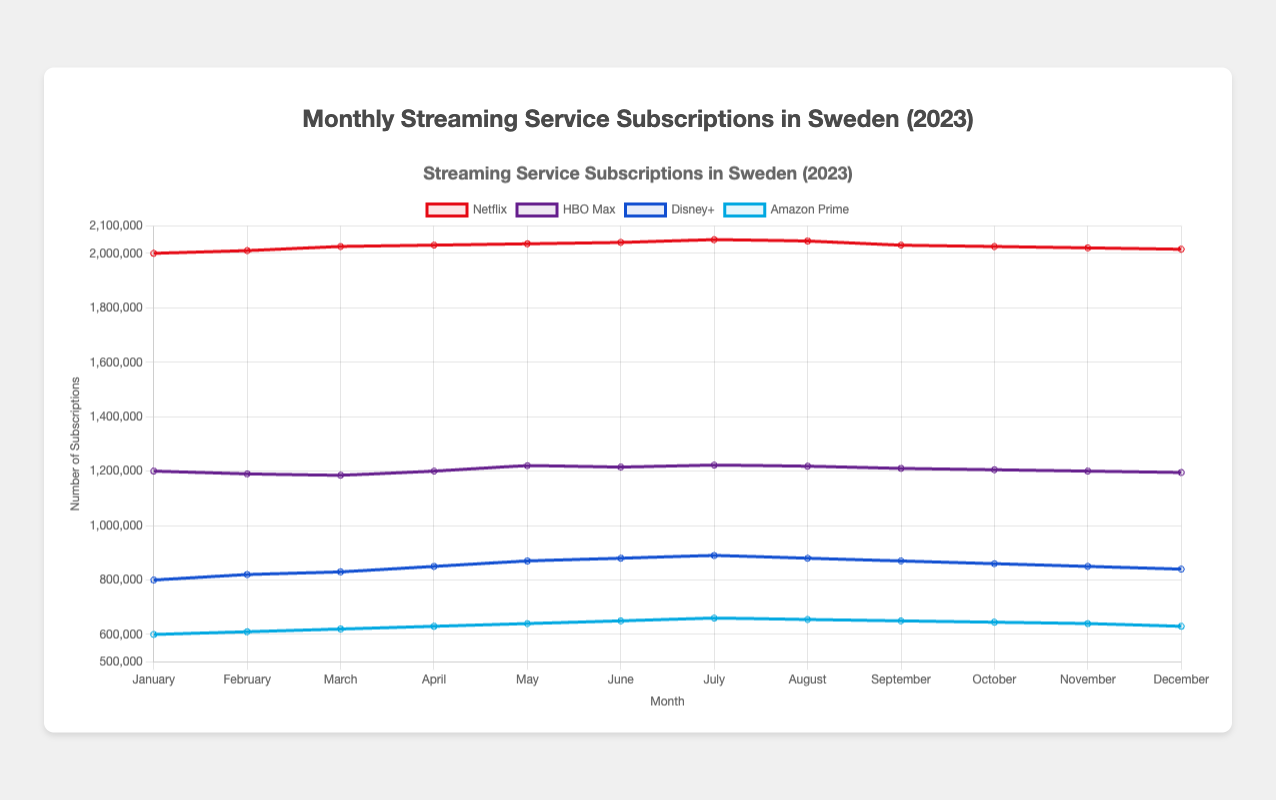Which streaming service had the highest number of subscriptions in July 2023? By looking at the data for July 2023, Netflix had the highest number of subscriptions among all streaming services with 2,050,000 subscriptions
Answer: Netflix In which month did HBO Max have its lowest number of subscriptions, and what was that number? HBO Max had its lowest number of subscriptions in March 2023 with 1,185,000 subscriptions
Answer: March, 1,185,000 What's the average number of Netflix subscriptions over the entire year of 2023? To get the average, add up all the Netflix subscription numbers and then divide by the number of months (12). The sum is 24,237,000, so the average is 24,237,000 / 12 = 2,019,750
Answer: 2,019,750 Did Disney+ subscriptions increase or decrease from June to August 2023, and by how much? Disney+ subscriptions decreased from June (880,000) to August (880,000), so the difference is zero due to no change
Answer: Decreased, 0 Which month experienced the highest Amazon Prime subscriptions increase compared to the previous month? Comparing each month's Amazon Prime subscriptions with the previous month's, the highest increase happened in July 2023 (660,000 - 650,000 = 10,000)
Answer: July, 10,000 Between January and December 2023, how did the number of Netflix subscriptions change, and what was the difference? Netflix subscriptions decreased from 2,000,000 in January to 2,015,000 in December, showing a net increase of 15,000
Answer: Increased, 15,000 What's the total number of HBO Max subscriptions for the entire year of 2023? Adding the HBO Max subscriptions for all the months, we get a total of 14,406,000
Answer: 14,406,000 Which month showed a significant rise in Disney+ subscriptions, and what was the popular film during that month? Disney+ subscriptions showed a significant rise in May 2023, with "Doctor Strange in the Multiverse of Madness" being the popular film
Answer: May, "Doctor Strange in the Multiverse of Madness" In which month did Amazon Prime subscriptions reach their peak, and how many subscriptions were there? Amazon Prime subscriptions peaked in July 2023 with a total of 660,000 subscriptions
Answer: July, 660,000 Compare the subscriptions of Netflix and HBO Max in October 2023. Which service had more, and by what amount? In October 2023, Netflix had 2,025,000 subscriptions, and HBO Max had 1,205,000 subscriptions. Netflix had 820,000 more subscriptions than HBO Max
Answer: Netflix, 820,000 